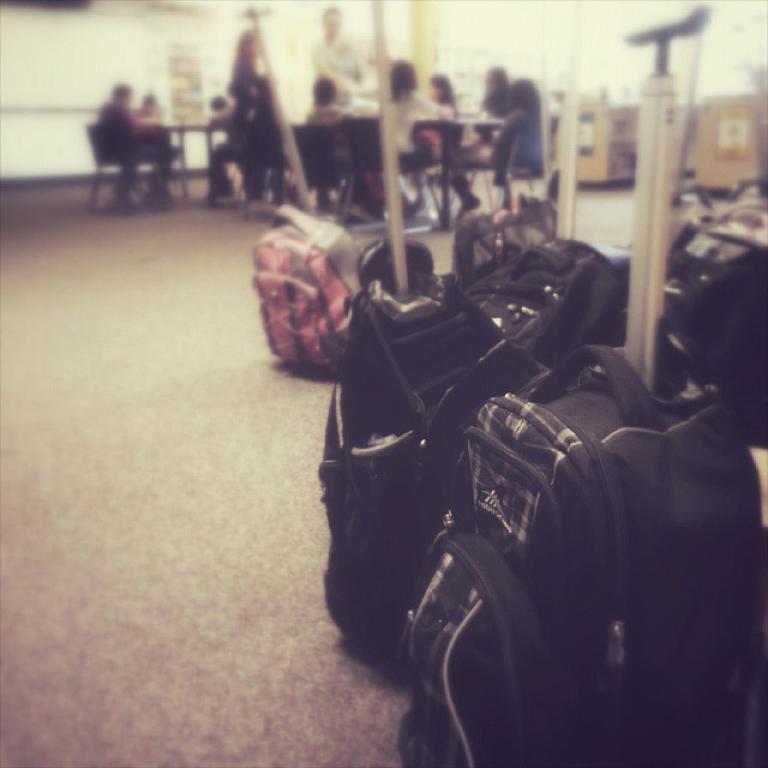Describe this image in one or two sentences. In this picture we can see luggage bags on the floor. In the background of the image it is blurry and there are people, among them few people sitting on chairs and we can see wall and objects. 